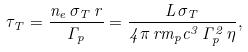Convert formula to latex. <formula><loc_0><loc_0><loc_500><loc_500>\tau _ { T } = \frac { n _ { e } \, \sigma _ { T } \, r } { \Gamma _ { p } } = \frac { L \, \sigma _ { T } } { 4 \pi \, r m _ { p } c ^ { 3 } \, \Gamma _ { p } ^ { 2 } \, \eta } ,</formula> 